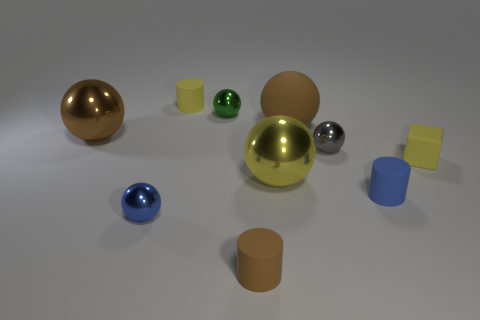Does the small brown thing have the same material as the blue cylinder?
Provide a succinct answer. Yes. The small yellow object that is right of the small cylinder behind the large metal object that is in front of the brown shiny thing is what shape?
Your answer should be very brief. Cube. Is the number of big brown shiny things that are right of the tiny yellow matte block less than the number of tiny spheres right of the large yellow ball?
Your answer should be compact. Yes. The tiny blue object left of the tiny yellow thing on the left side of the tiny rubber block is what shape?
Offer a terse response. Sphere. Is there anything else of the same color as the tiny matte block?
Make the answer very short. Yes. What number of green objects are either metallic things or tiny rubber cubes?
Your response must be concise. 1. Is the number of blocks on the left side of the yellow rubber cube less than the number of large cubes?
Your response must be concise. No. How many small cylinders are to the left of the big shiny sphere that is in front of the small gray shiny sphere?
Make the answer very short. 2. What number of other things are there of the same size as the green sphere?
Your answer should be very brief. 6. How many things are either gray objects or small shiny spheres in front of the brown matte ball?
Your answer should be compact. 2. 